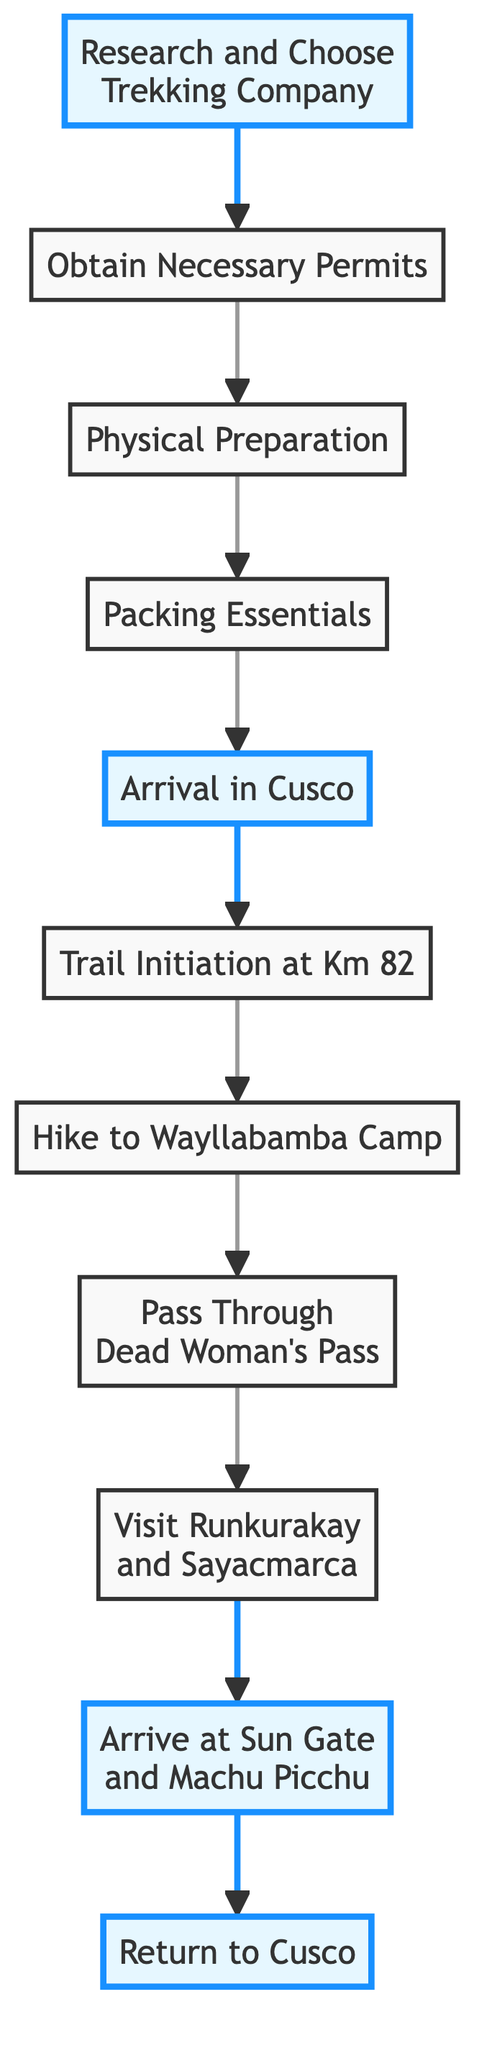What is the first step in the guide? The initial step in the diagram is represented by node A, labeled "Research and Choose a Trekking Company." This is the starting point of the flow.
Answer: Research and Choose a Trekking Company How many steps are there in the Inca Trail guide? To determine the total number of steps, we count the nodes in the diagram, which include A through K. This gives us a total of 11 steps.
Answer: 11 What do you do after obtaining necessary permits? Looking at the flow, after the step labeled "Obtain Necessary Permits" (node B), the next step is "Physical Preparation" (node C). This describes the subsequent action after permits are secured.
Answer: Physical Preparation What is the last action in the diagram? The final action is indicated by node K, which states "Return to Cusco." This is the endpoint of the flow chart showing the completion of the trekking process.
Answer: Return to Cusco Which step requires physical endurance building? In the diagram, node C titled "Physical Preparation" specifically mentions the need to build physical endurance through various exercises and acclimatization. This node clearly signifies the focus on physical conditioning.
Answer: Physical Preparation What is the altitude of Dead Woman's Pass? The description in node H mentions that Dead Woman’s Pass (node H) has an altitude of 4,215 meters. This is a key detail noted during the second day's hike.
Answer: 4,215 meters Which steps highlight important points in the journey? The steps highlighted in the diagram are A (Research and Choose Trekking Company), E (Arrival in Cusco), J (Arrive at Sun Gate and Machu Picchu), and K (Return to Cusco). These represent critical moments in the hiking experience.
Answer: A, E, J, K What step follows "Hike to Wayllabamba Camp"? Located right after node G, the subsequent step is H, which details "Pass Through Dead Woman’s Pass." The flow of the chart clearly shows this progression.
Answer: Pass Through Dead Woman’s Pass What preparation is required before hiking? Before the actual hiking begins, node E indicates the need for acclimatization during the "Arrival in Cusco" phase, which is crucial for high-altitude trekking.
Answer: Acclimatization 